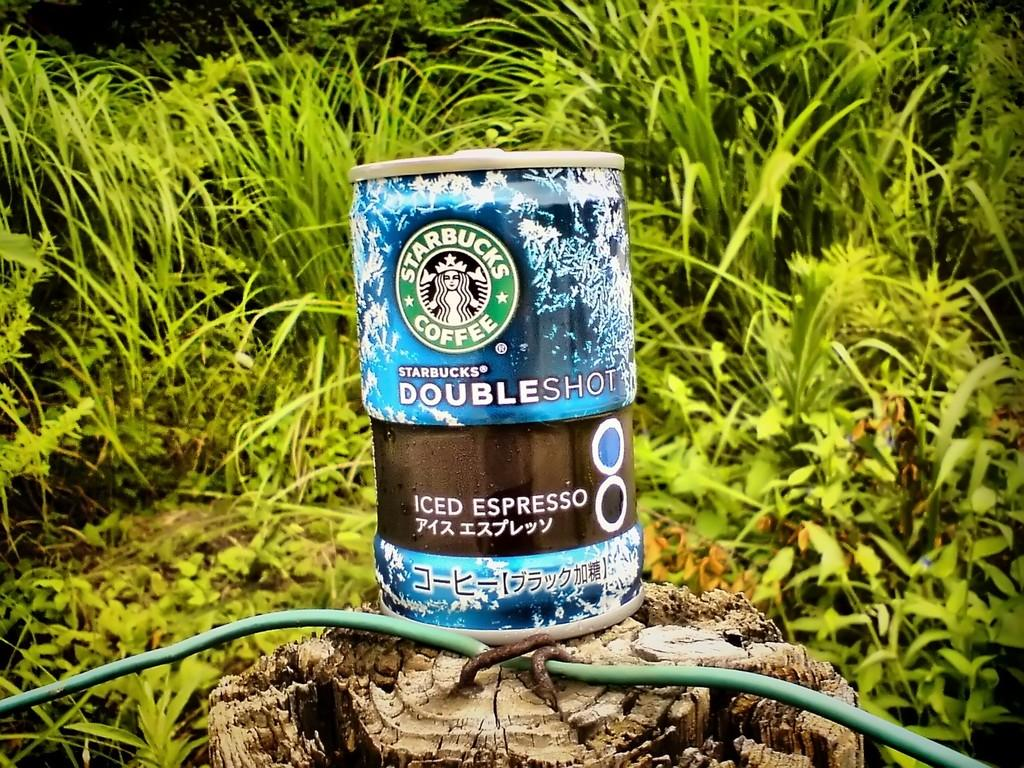What is the main object in the center of the image? There is an object in the center of the image, and it is accompanied by a wire. Can you describe the object in the center of the image? The object in the center of the image has a wire attached to it. What other objects can be seen in the image? There is a wood trunk in the image. What can be seen in the background of the image? There are plants in the background of the image. Reasoning: Let'ing: Let's think step by step in order to produce the conversation. We start by identifying the main subject in the image, which is the object in the center. Then, we describe the object in more detail by mentioning the wire that is attached to it. Next, we expand the conversation to include other objects that are also visible, such as the wood trunk. Finally, we describe the background of the image, which features plants. Absurd Question/Answer: What type of orange is being used as a basin in the image? There is no orange or basin present in the image. How many people are in the group that is sitting on the wood trunk in the image? There is no group of people sitting on the wood trunk in the image. 